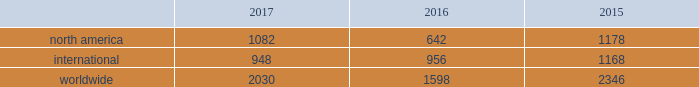Bhge 2017 form 10-k | 29 the rig counts are summarized in the table below as averages for each of the periods indicated. .
2017 compared to 2016 overall the rig count was 2030 in 2017 , an increase of 27% ( 27 % ) as compared to 2016 due primarily to north american activity .
The rig count in north america increased 69% ( 69 % ) in 2017 compared to 2016 .
Internationally , the rig count decreased 1% ( 1 % ) in 2017 as compared to the same period last year .
Within north america , the increase was primarily driven by the land rig count , which was up 72% ( 72 % ) , partially offset by a decrease in the offshore rig count of 16% ( 16 % ) .
Internationally , the rig count decrease was driven primarily by decreases in latin america of 7% ( 7 % ) , the europe region and africa region , which were down by 4% ( 4 % ) and 2% ( 2 % ) , respectively , partially offset by the asia-pacific region , which was up 8% ( 8 % ) .
2016 compared to 2015 overall the rig count was 1598 in 2016 , a decrease of 32% ( 32 % ) as compared to 2015 due primarily to north american activity .
The rig count in north america decreased 46% ( 46 % ) in 2016 compared to 2015 .
Internationally , the rig count decreased 18% ( 18 % ) in 2016 compared to 2015 .
Within north america , the decrease was primarily driven by a 44% ( 44 % ) decline in oil-directed rigs .
The natural gas- directed rig count in north america declined 50% ( 50 % ) in 2016 as natural gas well productivity improved .
Internationally , the rig count decrease was driven primarily by decreases in latin america , which was down 38% ( 38 % ) , the africa region , which was down 20% ( 20 % ) , and the europe region and asia-pacific region , which were down 18% ( 18 % ) and 15% ( 15 % ) , respectively .
Key performance indicators ( millions ) product services and backlog of product services our consolidated and combined statement of income ( loss ) displays sales and costs of sales in accordance with sec regulations under which "goods" is required to include all sales of tangible products and "services" must include all other sales , including other service activities .
For the amounts shown below , we distinguish between "equipment" and "product services" , where product services refer to sales under product services agreements , including sales of both goods ( such as spare parts and equipment upgrades ) and related services ( such as monitoring , maintenance and repairs ) , which is an important part of its operations .
We refer to "product services" simply as "services" within the business environment section of management's discussion and analysis .
Backlog is defined as unfilled customer orders for products and services believed to be firm .
For product services , an amount is included for the expected life of the contract. .
What portion of the rig counts is related to north america in 2017? 
Computations: (1082 / 2030)
Answer: 0.533. 